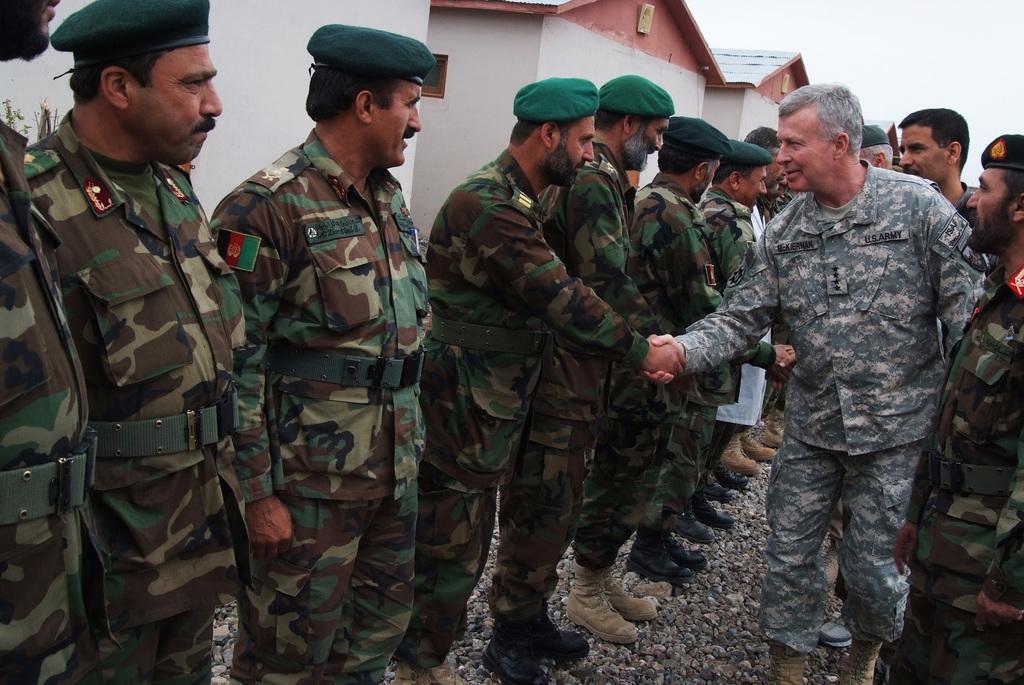Please provide a concise description of this image. In this picture we can see a group of people are standing and wearing a uniform and some of them are wearing caps. In the background of the image we can see the houses, roof. In the top right corner we can see the sky. At the bottom of the image we can see the stones. 